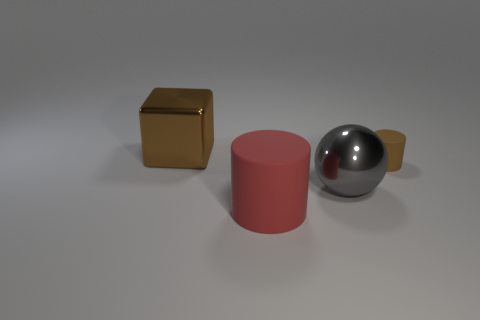Add 4 small blue metallic blocks. How many objects exist? 8 Subtract all spheres. How many objects are left? 3 Add 3 big gray matte objects. How many big gray matte objects exist? 3 Subtract 0 cyan blocks. How many objects are left? 4 Subtract all purple rubber balls. Subtract all large red rubber objects. How many objects are left? 3 Add 3 big brown metallic cubes. How many big brown metallic cubes are left? 4 